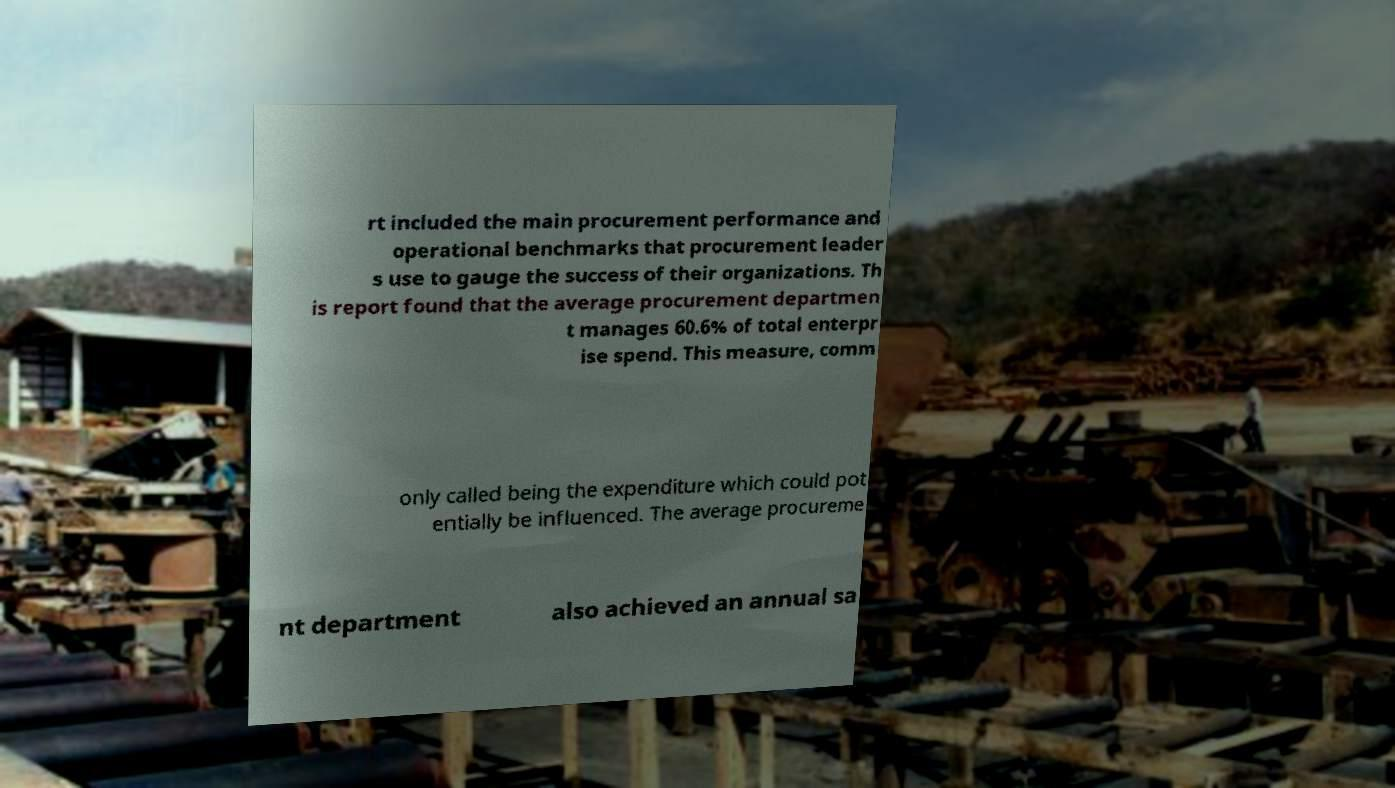There's text embedded in this image that I need extracted. Can you transcribe it verbatim? rt included the main procurement performance and operational benchmarks that procurement leader s use to gauge the success of their organizations. Th is report found that the average procurement departmen t manages 60.6% of total enterpr ise spend. This measure, comm only called being the expenditure which could pot entially be influenced. The average procureme nt department also achieved an annual sa 